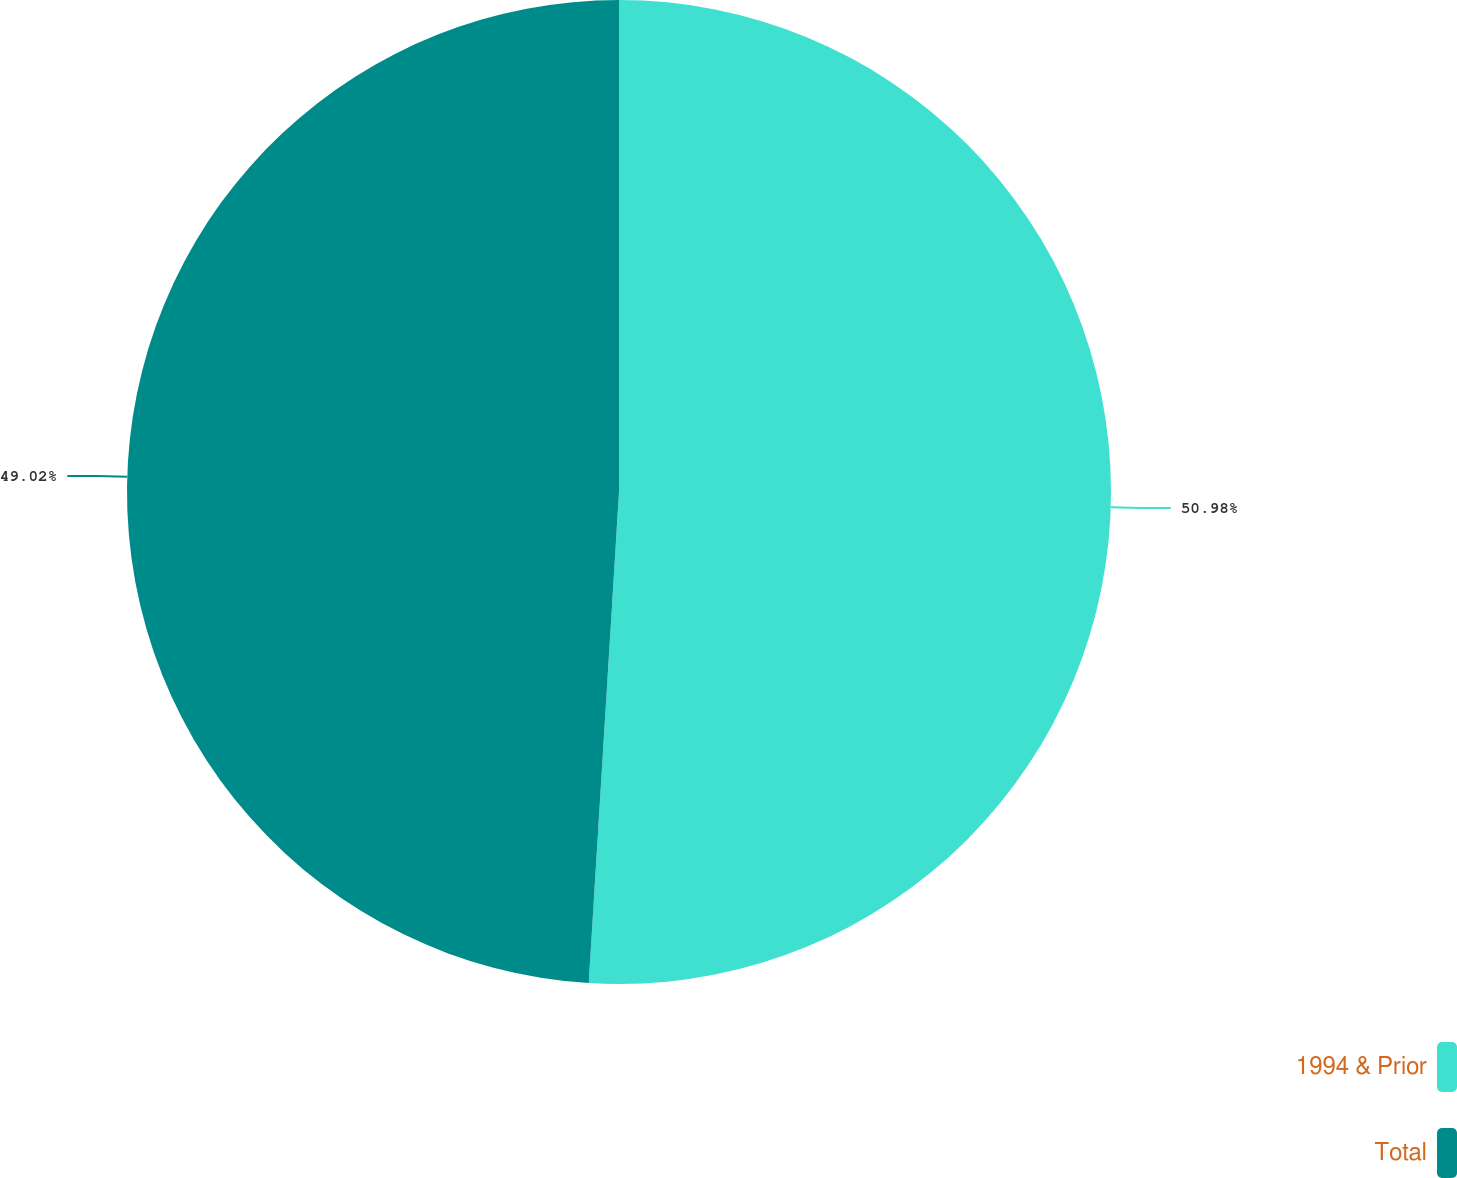Convert chart to OTSL. <chart><loc_0><loc_0><loc_500><loc_500><pie_chart><fcel>1994 & Prior<fcel>Total<nl><fcel>50.98%<fcel>49.02%<nl></chart> 